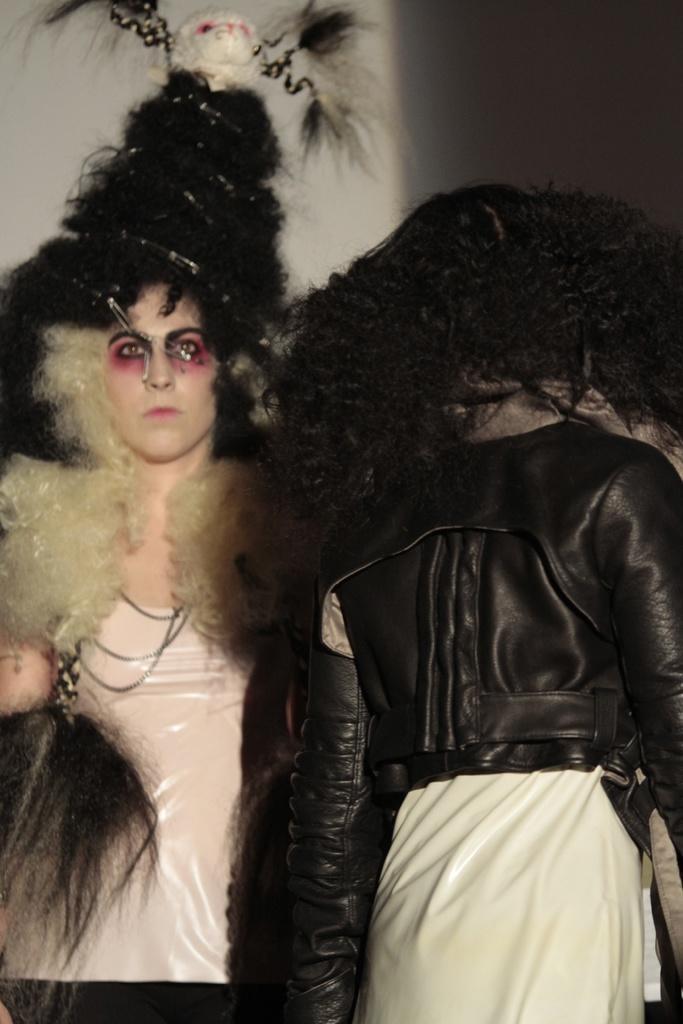In one or two sentences, can you explain what this image depicts? In this image, we can see two people. Background there is a white color. 